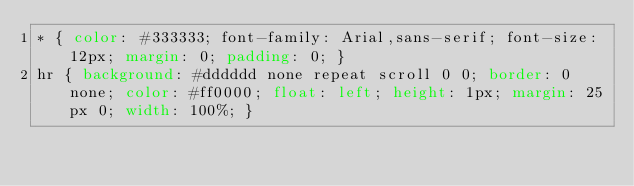<code> <loc_0><loc_0><loc_500><loc_500><_CSS_>* { color: #333333; font-family: Arial,sans-serif; font-size: 12px; margin: 0; padding: 0; }
hr { background: #dddddd none repeat scroll 0 0; border: 0 none; color: #ff0000; float: left; height: 1px; margin: 25px 0; width: 100%; }
</code> 